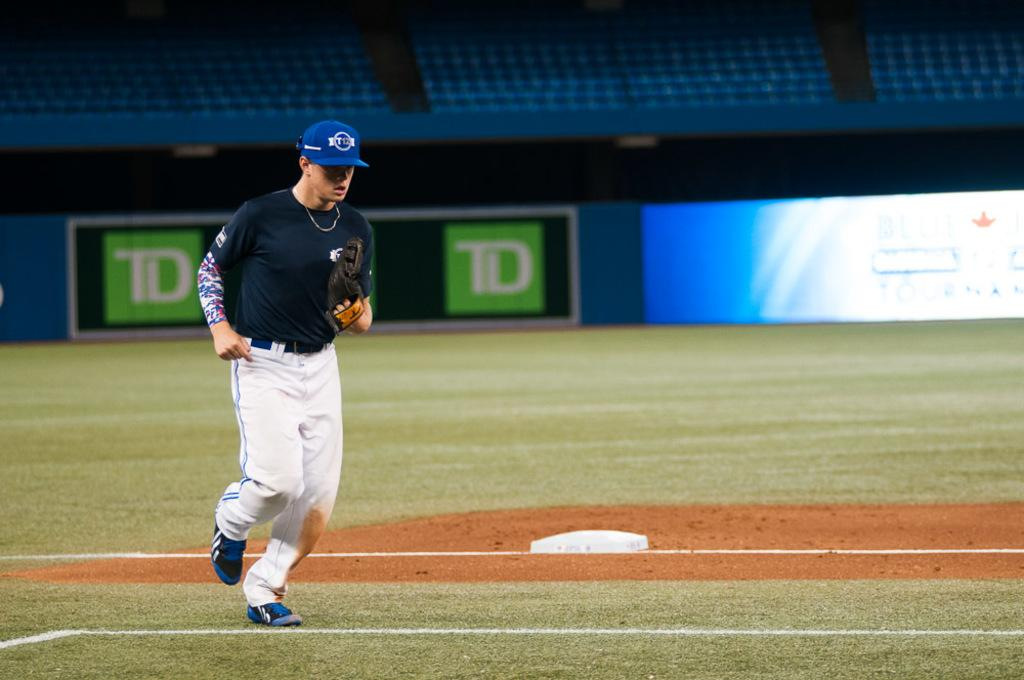Provide a one-sentence caption for the provided image. a baseball player runs on a field with TD on it. 